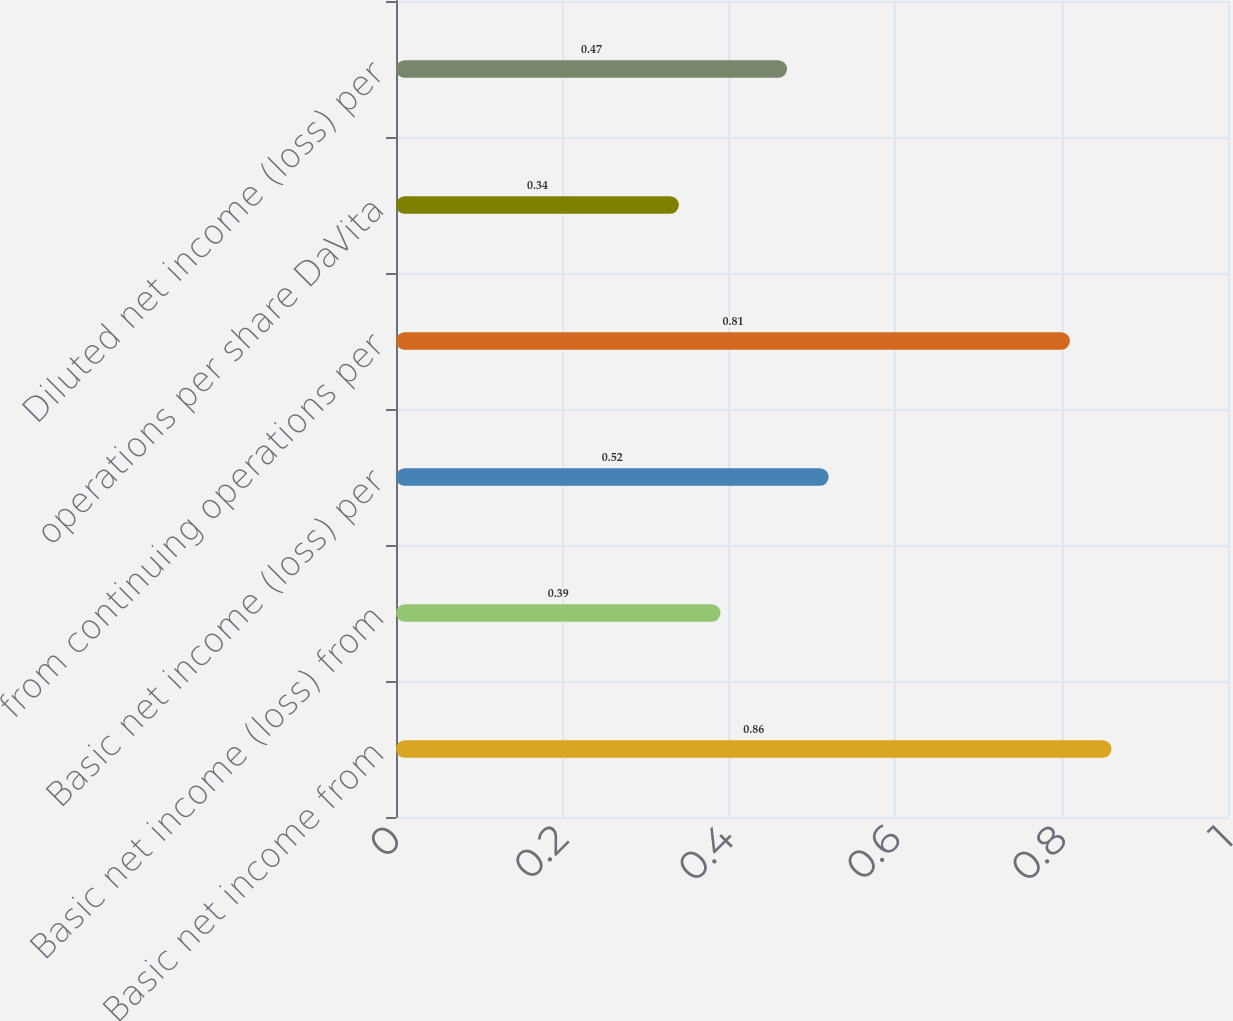Convert chart. <chart><loc_0><loc_0><loc_500><loc_500><bar_chart><fcel>Basic net income from<fcel>Basic net income (loss) from<fcel>Basic net income (loss) per<fcel>from continuing operations per<fcel>operations per share DaVita<fcel>Diluted net income (loss) per<nl><fcel>0.86<fcel>0.39<fcel>0.52<fcel>0.81<fcel>0.34<fcel>0.47<nl></chart> 